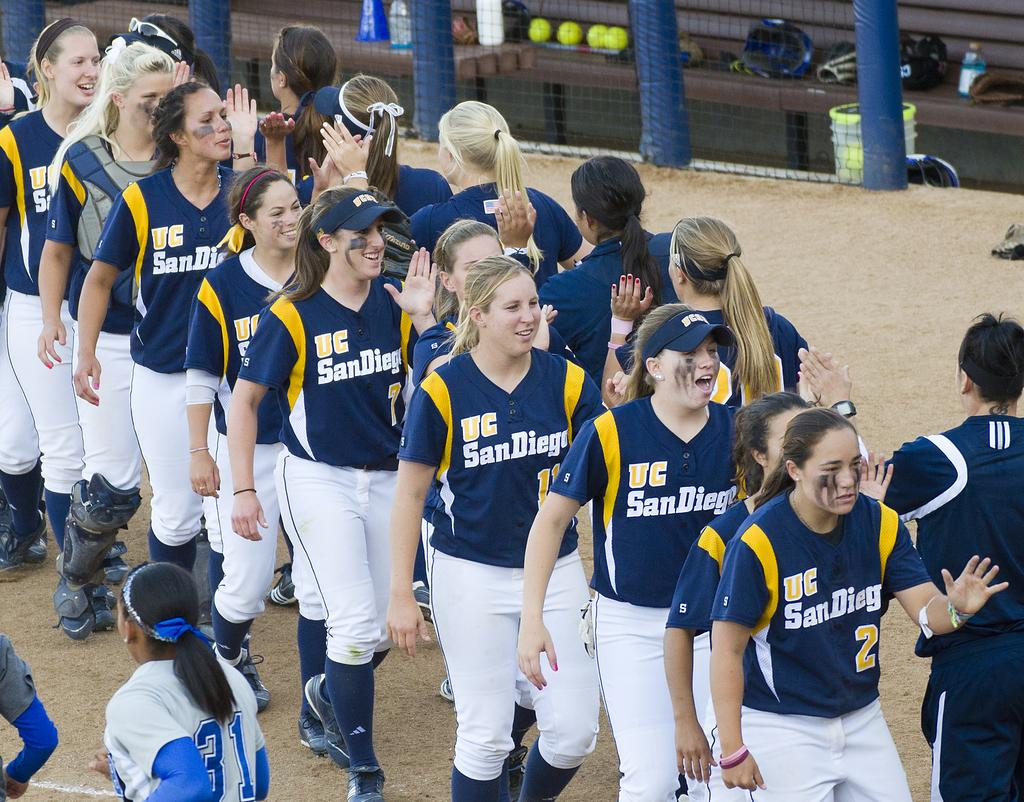<image>
Offer a succinct explanation of the picture presented. The group of girls shown play for San Diego. 